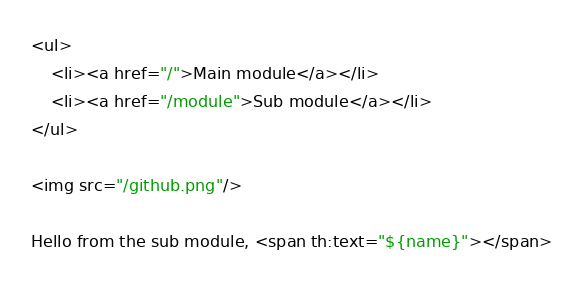Convert code to text. <code><loc_0><loc_0><loc_500><loc_500><_HTML_><ul>
    <li><a href="/">Main module</a></li>
    <li><a href="/module">Sub module</a></li>
</ul>

<img src="/github.png"/>

Hello from the sub module, <span th:text="${name}"></span>
</code> 